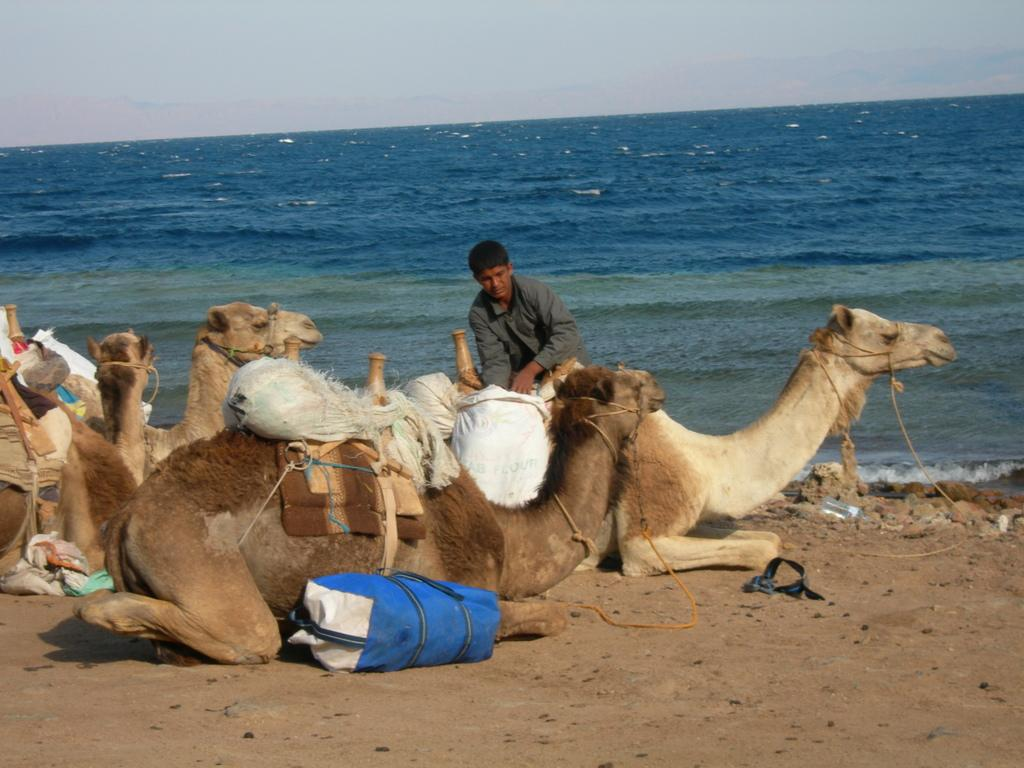What animals are present in the image? There are camels in the picture. What are the camels carrying? The camels are carrying bags. Is there a person riding one of the camels? Yes, there is a person sitting on one of the camels. What can be seen in the background of the image? There is water visible in the background of the image. What type of tree can be seen in the image? There is no tree present in the image; it features camels carrying bags and a person sitting on one of them, with water visible in the background. 